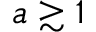<formula> <loc_0><loc_0><loc_500><loc_500>a \gtrsim 1</formula> 